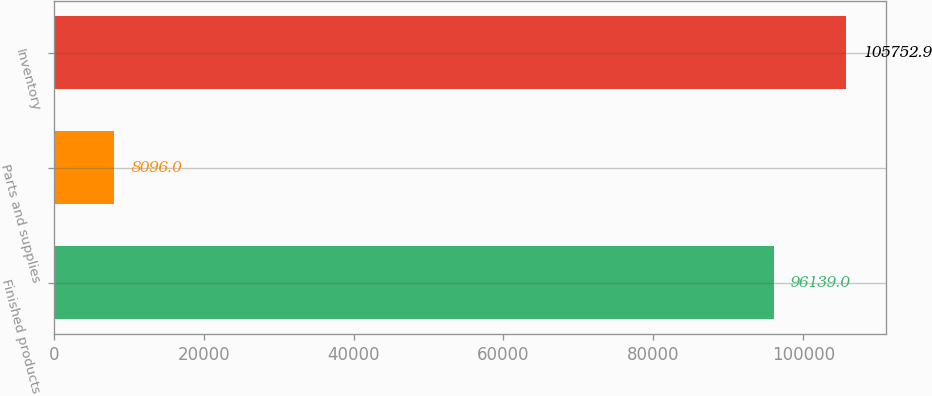Convert chart. <chart><loc_0><loc_0><loc_500><loc_500><bar_chart><fcel>Finished products<fcel>Parts and supplies<fcel>Inventory<nl><fcel>96139<fcel>8096<fcel>105753<nl></chart> 